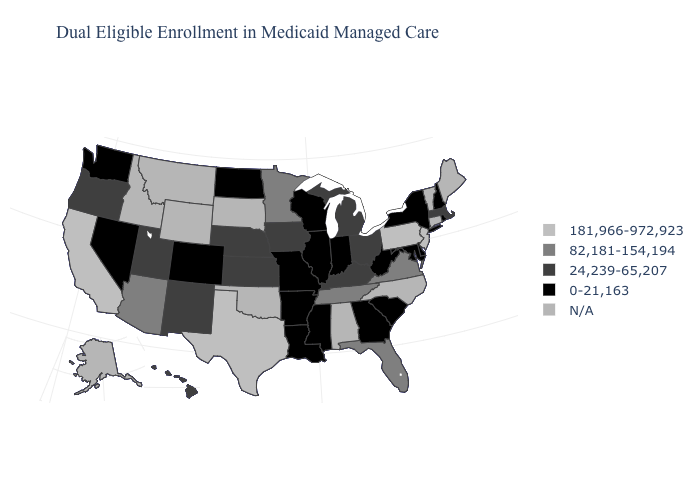Which states hav the highest value in the Northeast?
Quick response, please. New Jersey, Pennsylvania. How many symbols are there in the legend?
Be succinct. 5. What is the value of Hawaii?
Concise answer only. 24,239-65,207. Name the states that have a value in the range 181,966-972,923?
Write a very short answer. California, New Jersey, Pennsylvania, Texas. Name the states that have a value in the range N/A?
Keep it brief. Alabama, Alaska, Connecticut, Idaho, Maine, Montana, North Carolina, Oklahoma, South Dakota, Vermont, Wyoming. What is the lowest value in the USA?
Concise answer only. 0-21,163. Does the first symbol in the legend represent the smallest category?
Be succinct. No. Among the states that border Maryland , does Delaware have the highest value?
Keep it brief. No. What is the value of New Jersey?
Give a very brief answer. 181,966-972,923. What is the value of Delaware?
Keep it brief. 0-21,163. What is the value of Maine?
Be succinct. N/A. What is the lowest value in the West?
Concise answer only. 0-21,163. Name the states that have a value in the range N/A?
Short answer required. Alabama, Alaska, Connecticut, Idaho, Maine, Montana, North Carolina, Oklahoma, South Dakota, Vermont, Wyoming. Which states have the lowest value in the West?
Short answer required. Colorado, Nevada, Washington. What is the highest value in states that border Colorado?
Write a very short answer. 82,181-154,194. 